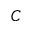<formula> <loc_0><loc_0><loc_500><loc_500>C</formula> 